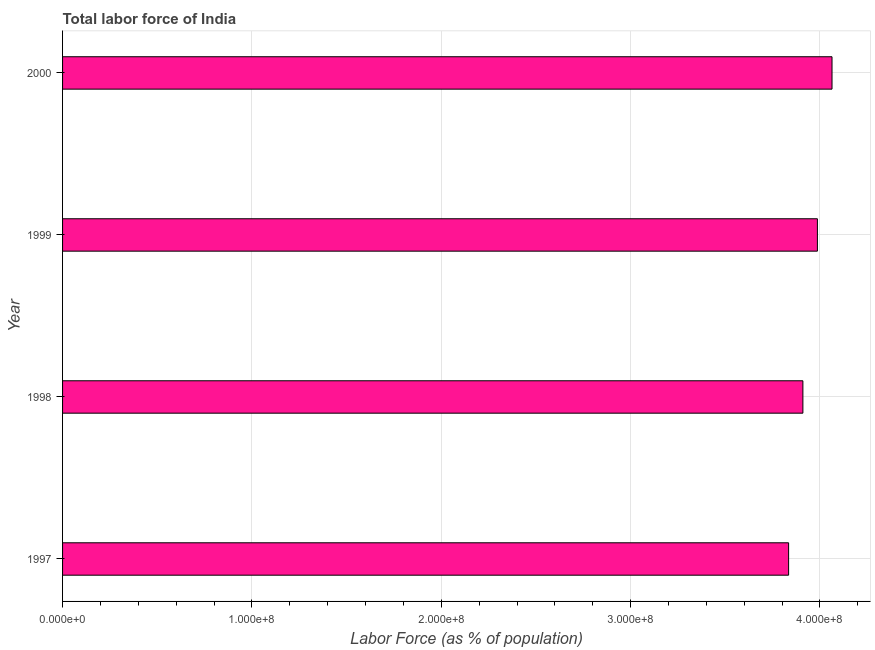Does the graph contain grids?
Your answer should be very brief. Yes. What is the title of the graph?
Make the answer very short. Total labor force of India. What is the label or title of the X-axis?
Offer a very short reply. Labor Force (as % of population). What is the label or title of the Y-axis?
Make the answer very short. Year. What is the total labor force in 1998?
Keep it short and to the point. 3.91e+08. Across all years, what is the maximum total labor force?
Provide a short and direct response. 4.06e+08. Across all years, what is the minimum total labor force?
Your answer should be very brief. 3.83e+08. In which year was the total labor force minimum?
Provide a succinct answer. 1997. What is the sum of the total labor force?
Give a very brief answer. 1.58e+09. What is the difference between the total labor force in 1997 and 1999?
Your answer should be very brief. -1.52e+07. What is the average total labor force per year?
Give a very brief answer. 3.95e+08. What is the median total labor force?
Your response must be concise. 3.95e+08. What is the ratio of the total labor force in 1997 to that in 2000?
Keep it short and to the point. 0.94. Is the difference between the total labor force in 1998 and 1999 greater than the difference between any two years?
Offer a very short reply. No. What is the difference between the highest and the second highest total labor force?
Give a very brief answer. 7.72e+06. Is the sum of the total labor force in 1997 and 2000 greater than the maximum total labor force across all years?
Provide a short and direct response. Yes. What is the difference between the highest and the lowest total labor force?
Give a very brief answer. 2.29e+07. In how many years, is the total labor force greater than the average total labor force taken over all years?
Your answer should be very brief. 2. What is the difference between two consecutive major ticks on the X-axis?
Make the answer very short. 1.00e+08. Are the values on the major ticks of X-axis written in scientific E-notation?
Provide a succinct answer. Yes. What is the Labor Force (as % of population) of 1997?
Provide a short and direct response. 3.83e+08. What is the Labor Force (as % of population) in 1998?
Your answer should be very brief. 3.91e+08. What is the Labor Force (as % of population) of 1999?
Offer a terse response. 3.99e+08. What is the Labor Force (as % of population) of 2000?
Keep it short and to the point. 4.06e+08. What is the difference between the Labor Force (as % of population) in 1997 and 1998?
Provide a short and direct response. -7.54e+06. What is the difference between the Labor Force (as % of population) in 1997 and 1999?
Give a very brief answer. -1.52e+07. What is the difference between the Labor Force (as % of population) in 1997 and 2000?
Keep it short and to the point. -2.29e+07. What is the difference between the Labor Force (as % of population) in 1998 and 1999?
Provide a short and direct response. -7.66e+06. What is the difference between the Labor Force (as % of population) in 1998 and 2000?
Your answer should be very brief. -1.54e+07. What is the difference between the Labor Force (as % of population) in 1999 and 2000?
Provide a succinct answer. -7.72e+06. What is the ratio of the Labor Force (as % of population) in 1997 to that in 2000?
Make the answer very short. 0.94. What is the ratio of the Labor Force (as % of population) in 1998 to that in 1999?
Give a very brief answer. 0.98. What is the ratio of the Labor Force (as % of population) in 1998 to that in 2000?
Provide a short and direct response. 0.96. 